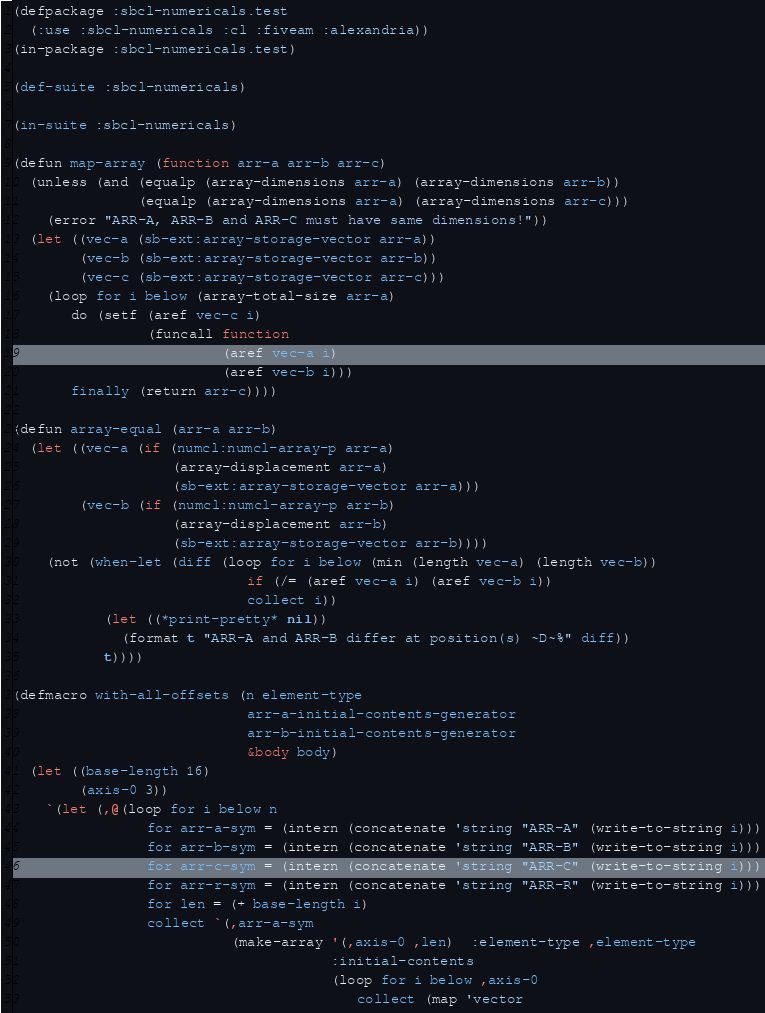<code> <loc_0><loc_0><loc_500><loc_500><_Lisp_>(defpackage :sbcl-numericals.test
  (:use :sbcl-numericals :cl :fiveam :alexandria))
(in-package :sbcl-numericals.test)

(def-suite :sbcl-numericals)

(in-suite :sbcl-numericals)

(defun map-array (function arr-a arr-b arr-c)
  (unless (and (equalp (array-dimensions arr-a) (array-dimensions arr-b))
               (equalp (array-dimensions arr-a) (array-dimensions arr-c)))
    (error "ARR-A, ARR-B and ARR-C must have same dimensions!"))
  (let ((vec-a (sb-ext:array-storage-vector arr-a))
        (vec-b (sb-ext:array-storage-vector arr-b))
        (vec-c (sb-ext:array-storage-vector arr-c)))
    (loop for i below (array-total-size arr-a)
       do (setf (aref vec-c i)
                (funcall function
                         (aref vec-a i)
                         (aref vec-b i)))
       finally (return arr-c))))

(defun array-equal (arr-a arr-b)
  (let ((vec-a (if (numcl:numcl-array-p arr-a)
                   (array-displacement arr-a)
                   (sb-ext:array-storage-vector arr-a)))
        (vec-b (if (numcl:numcl-array-p arr-b)
                   (array-displacement arr-b)
                   (sb-ext:array-storage-vector arr-b))))
    (not (when-let (diff (loop for i below (min (length vec-a) (length vec-b))
                            if (/= (aref vec-a i) (aref vec-b i))
                            collect i))
           (let ((*print-pretty* nil))
             (format t "ARR-A and ARR-B differ at position(s) ~D~%" diff))
           t))))

(defmacro with-all-offsets (n element-type
                            arr-a-initial-contents-generator
                            arr-b-initial-contents-generator
                            &body body)
  (let ((base-length 16)
        (axis-0 3))
    `(let (,@(loop for i below n
                for arr-a-sym = (intern (concatenate 'string "ARR-A" (write-to-string i)))
                for arr-b-sym = (intern (concatenate 'string "ARR-B" (write-to-string i)))
                for arr-c-sym = (intern (concatenate 'string "ARR-C" (write-to-string i)))
                for arr-r-sym = (intern (concatenate 'string "ARR-R" (write-to-string i)))
                for len = (+ base-length i)
                collect `(,arr-a-sym
                          (make-array '(,axis-0 ,len)  :element-type ,element-type
                                      :initial-contents
                                      (loop for i below ,axis-0
                                         collect (map 'vector</code> 